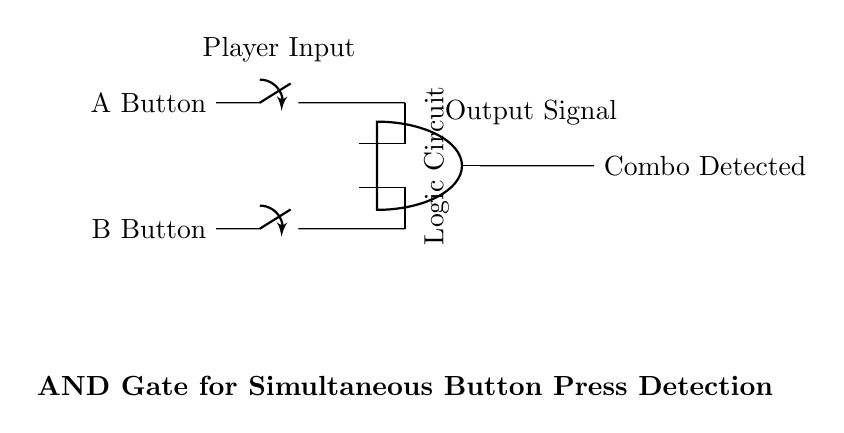What components are in this circuit? The circuit contains two switches (A Button and B Button) and one AND gate. The switches represent the buttons being pressed, while the AND gate processes the signals from these buttons.
Answer: Two switches and one AND gate What is the output of the circuit when both buttons are pressed? In an AND gate logic, the output is true (or high) only when both inputs are high. Thus, if both buttons A and B are pressed, the output will indicate "Combo Detected."
Answer: Combo Detected What type of logic gate is used in this circuit? The circuit uses an AND gate, which requires both inputs to be true for the output to be true.
Answer: AND gate How many input connections does the AND gate have? The AND gate has two input connections, corresponding to the A Button and B Button in this circuit.
Answer: Two If only the A Button is pressed, what is the output? In the case where only the A Button is pressed, the input to the AND gate from B remains low. Since the AND gate requires both inputs to be high, the output will be low (or false).
Answer: Low What does the 'Player Input' label indicate? The 'Player Input' label signifies where the player's button presses (A and B Buttons) are represented in the schematic, indicating the source of the signals feeding into the AND gate.
Answer: Player Inputs 